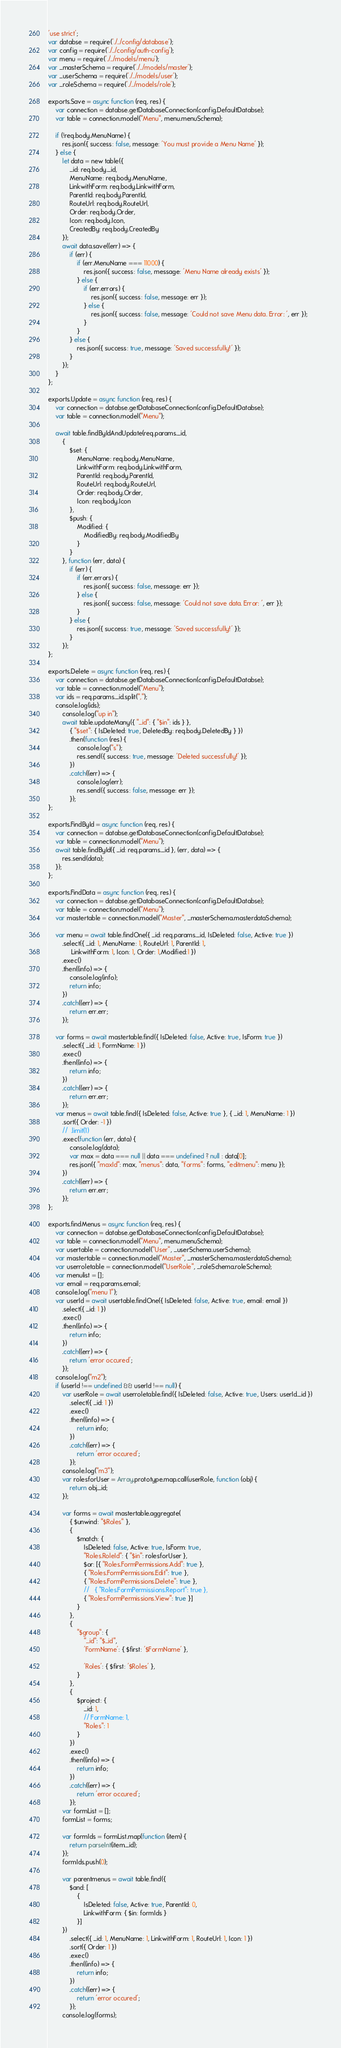<code> <loc_0><loc_0><loc_500><loc_500><_JavaScript_>
'use strict';
var databse = require('./../config/database');
var config = require('./../config/auth-config');
var menu = require('./../models/menu');
var _masterSchema = require('./../models/master');
var _userSchema = require('./../models/user');
var _roleSchema = require('./../models/role');

exports.Save = async function (req, res) {
    var connection = databse.getDatabaseConnection(config.DefaultDatabse);
    var table = connection.model("Menu", menu.menuSchema);

    if (!req.body.MenuName) {
        res.json({ success: false, message: 'You must provide a Menu Name' });
    } else {
        let data = new table({
            _id: req.body._id,
            MenuName: req.body.MenuName,
            LinkwithForm: req.body.LinkwithForm,
            ParentId: req.body.ParentId,
            RouteUrl: req.body.RouteUrl,
            Order: req.body.Order,
            Icon: req.body.Icon,
            CreatedBy: req.body.CreatedBy
        });
        await data.save((err) => {
            if (err) {
                if (err.MenuName === 11000) {
                    res.json({ success: false, message: 'Menu Name already exists' });
                } else {
                    if (err.errors) {
                        res.json({ success: false, message: err });
                    } else {
                        res.json({ success: false, message: 'Could not save Menu data. Error: ', err });
                    }
                }
            } else {
                res.json({ success: true, message: 'Saved successfully!' });
            }
        });
    }
};

exports.Update = async function (req, res) {
    var connection = databse.getDatabaseConnection(config.DefaultDatabse);
    var table = connection.model("Menu");
     
    await table.findByIdAndUpdate(req.params._id,
        {
            $set: {
                MenuName: req.body.MenuName,
                LinkwithForm: req.body.LinkwithForm,
                ParentId: req.body.ParentId,
                RouteUrl: req.body.RouteUrl,
                Order: req.body.Order,
                Icon: req.body.Icon
            },
            $push: {
                Modified: {
                    ModifiedBy: req.body.ModifiedBy
                }
            }
        }, function (err, data) {
            if (err) {
                if (err.errors) {
                    res.json({ success: false, message: err });
                } else {
                    res.json({ success: false, message: 'Could not save data. Error: ', err });
                }
            } else {
                res.json({ success: true, message: 'Saved successfully!' });
            }
        });
};

exports.Delete = async function (req, res) {
    var connection = databse.getDatabaseConnection(config.DefaultDatabse);
    var table = connection.model("Menu");
    var ids = req.params._id.split(",");
    console.log(ids);
        console.log("up in");
        await table.updateMany({ "_id": { "$in": ids } },
            { "$set": { IsDeleted: true, DeletedBy: req.body.DeletedBy } })
            .then(function (res) {
                console.log("s");
                res.send({ success: true, message: 'Deleted successfully!' });
            })
            .catch((err) => {
                console.log(err);
                res.send({ success: false, message: err });
            });    
};

exports.FindById = async function (req, res) {
    var connection = databse.getDatabaseConnection(config.DefaultDatabse);
    var table = connection.model("Menu");
    await table.findById({ _id: req.params._id }, (err, data) => {
        res.send(data);
    });
};

exports.FindData = async function (req, res) {
    var connection = databse.getDatabaseConnection(config.DefaultDatabse);
    var table = connection.model("Menu");
    var mastertable = connection.model("Master", _masterSchema.masterdataSchema);

    var menu = await table.findOne({ _id: req.params._id, IsDeleted: false, Active: true })
        .select({ _id: 1, MenuName: 1, RouteUrl: 1, ParentId: 1,
             LinkwithForm: 1, Icon: 1, Order: 1,Modified:1 })
        .exec()
        .then((info) => {
            console.log(info);
            return info;
        })
        .catch((err) => {
            return err.err;
        });

    var forms = await mastertable.find({ IsDeleted: false, Active: true, IsForm: true })
        .select({ _id: 1, FormName: 1 })
        .exec()
        .then((info) => {
            return info;
        })
        .catch((err) => {
            return err.err;
        });
    var menus = await table.find({ IsDeleted: false, Active: true }, { _id: 1, MenuName: 1 })
        .sort({ Order: -1 })
        //  .limit(1)
        .exec(function (err, data) {
            console.log(data);
            var max = data === null || data === undefined ? null : data[0];
            res.json({ "maxId": max, "menus": data, "forms": forms, "editmenu": menu });
        })
        .catch((err) => {
            return err.err;
        });
};

exports.findMenus = async function (req, res) {
    var connection = databse.getDatabaseConnection(config.DefaultDatabse);
    var table = connection.model("Menu", menu.menuSchema);
    var usertable = connection.model("User", _userSchema.userSchema);
    var mastertable = connection.model("Master", _masterSchema.masterdataSchema);
    var userroletable = connection.model("UserRole", _roleSchema.roleSchema);
    var menulist = [];
    var email = req.params.email;
    console.log("menu 1");
    var userId = await usertable.findOne({ IsDeleted: false, Active: true, email: email })
        .select({ _id: 1 })
        .exec()
        .then((info) => {
            return info;
        })
        .catch((err) => {
            return 'error occured';
        });
    console.log("m2");
    if (userId !== undefined && userId !== null) {
        var userRole = await userroletable.find({ IsDeleted: false, Active: true, Users: userId._id })
            .select({ _id: 1 })
            .exec()
            .then((info) => {
                return info;
            })
            .catch((err) => {
                return 'error occured';
            });
        console.log("m3");
        var rolesforUser = Array.prototype.map.call(userRole, function (obj) {
            return obj._id;
        });

        var forms = await mastertable.aggregate(
            { $unwind: "$Roles" },
            {
                $match: {
                    IsDeleted: false, Active: true, IsForm: true,
                    "Roles.RoleId": { "$in": rolesforUser },
                    $or: [{ "Roles.FormPermissions.Add": true },
                    { "Roles.FormPermissions.Edit": true },
                    { "Roles.FormPermissions.Delete": true },
                    //   { "Roles.FormPermissions.Report": true },
                    { "Roles.FormPermissions.View": true }]
                }
            },
            {
                "$group": {
                    "_id": "$_id",
                    'FormName': { $first: '$FormName' },

                    'Roles': { $first: '$Roles' },
                }
            },
            {
                $project: {
                    _id: 1,
                    // FormName: 1,
                    "Roles": 1
                }
            })
            .exec()
            .then((info) => {
                return info;
            })
            .catch((err) => {
                return 'error occured';
            });
        var formList = [];
        formList = forms;

        var formIds = formList.map(function (item) {
            return parseInt(item._id);
        });
        formIds.push(0);

        var parentmenus = await table.find({
            $and: [
                {
                    IsDeleted: false, Active: true, ParentId: 0,
                    LinkwithForm: { $in: formIds }
                }]
        })
            .select({ _id: 1, MenuName: 1, LinkwithForm: 1, RouteUrl: 1, Icon: 1 })
            .sort({ Order: 1 })
            .exec()
            .then((info) => {
                return info;
            })
            .catch((err) => {
                return 'error occured';
            });
        console.log(forms);</code> 